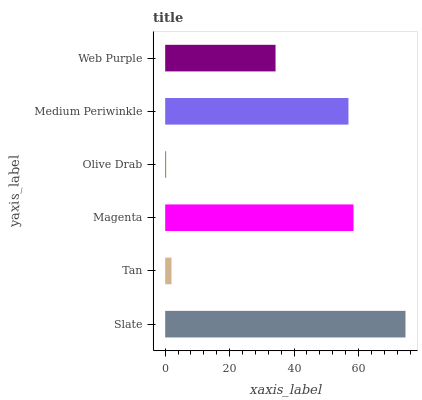Is Olive Drab the minimum?
Answer yes or no. Yes. Is Slate the maximum?
Answer yes or no. Yes. Is Tan the minimum?
Answer yes or no. No. Is Tan the maximum?
Answer yes or no. No. Is Slate greater than Tan?
Answer yes or no. Yes. Is Tan less than Slate?
Answer yes or no. Yes. Is Tan greater than Slate?
Answer yes or no. No. Is Slate less than Tan?
Answer yes or no. No. Is Medium Periwinkle the high median?
Answer yes or no. Yes. Is Web Purple the low median?
Answer yes or no. Yes. Is Web Purple the high median?
Answer yes or no. No. Is Olive Drab the low median?
Answer yes or no. No. 